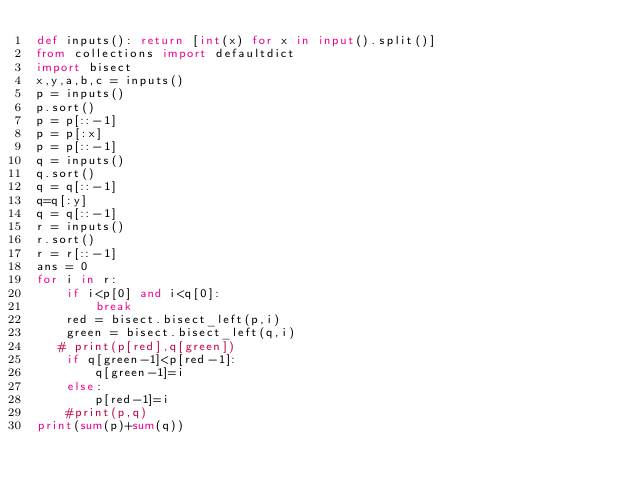Convert code to text. <code><loc_0><loc_0><loc_500><loc_500><_Python_>def inputs(): return [int(x) for x in input().split()]
from collections import defaultdict
import bisect
x,y,a,b,c = inputs()
p = inputs()
p.sort()
p = p[::-1]
p = p[:x]
p = p[::-1]
q = inputs()
q.sort()
q = q[::-1]
q=q[:y]
q = q[::-1]
r = inputs()
r.sort()
r = r[::-1]
ans = 0
for i in r:
    if i<p[0] and i<q[0]:
        break
    red = bisect.bisect_left(p,i)
    green = bisect.bisect_left(q,i)
   # print(p[red],q[green])
    if q[green-1]<p[red-1]:
        q[green-1]=i
    else:
        p[red-1]=i
    #print(p,q)
print(sum(p)+sum(q))

</code> 